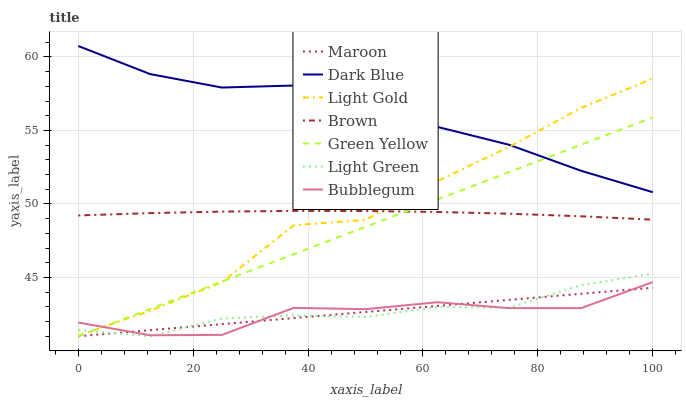Does Bubblegum have the minimum area under the curve?
Answer yes or no. Yes. Does Dark Blue have the maximum area under the curve?
Answer yes or no. Yes. Does Maroon have the minimum area under the curve?
Answer yes or no. No. Does Maroon have the maximum area under the curve?
Answer yes or no. No. Is Green Yellow the smoothest?
Answer yes or no. Yes. Is Light Gold the roughest?
Answer yes or no. Yes. Is Maroon the smoothest?
Answer yes or no. No. Is Maroon the roughest?
Answer yes or no. No. Does Maroon have the lowest value?
Answer yes or no. Yes. Does Dark Blue have the lowest value?
Answer yes or no. No. Does Dark Blue have the highest value?
Answer yes or no. Yes. Does Maroon have the highest value?
Answer yes or no. No. Is Bubblegum less than Dark Blue?
Answer yes or no. Yes. Is Dark Blue greater than Light Green?
Answer yes or no. Yes. Does Green Yellow intersect Light Gold?
Answer yes or no. Yes. Is Green Yellow less than Light Gold?
Answer yes or no. No. Is Green Yellow greater than Light Gold?
Answer yes or no. No. Does Bubblegum intersect Dark Blue?
Answer yes or no. No. 